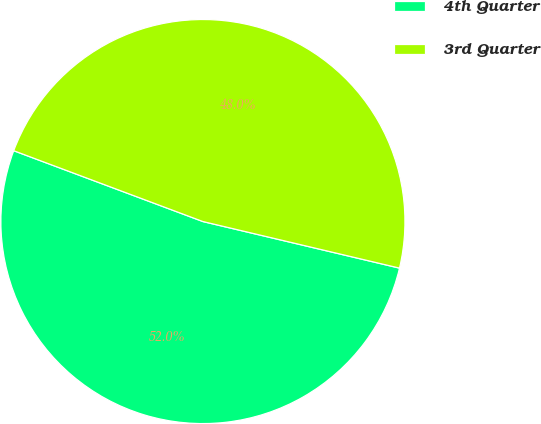Convert chart to OTSL. <chart><loc_0><loc_0><loc_500><loc_500><pie_chart><fcel>4th Quarter<fcel>3rd Quarter<nl><fcel>52.0%<fcel>48.0%<nl></chart> 